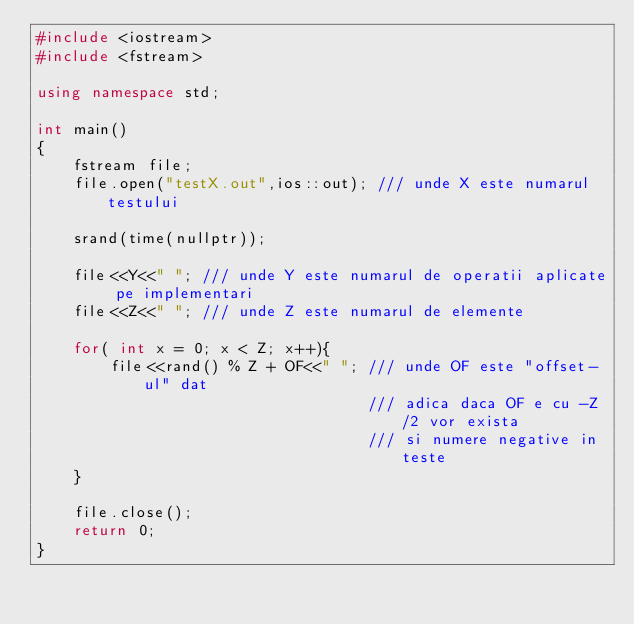Convert code to text. <code><loc_0><loc_0><loc_500><loc_500><_C++_>#include <iostream>
#include <fstream>

using namespace std;

int main()
{
    fstream file;
    file.open("testX.out",ios::out); /// unde X este numarul testului

    srand(time(nullptr));

    file<<Y<<" "; /// unde Y este numarul de operatii aplicate pe implementari
    file<<Z<<" "; /// unde Z este numarul de elemente

    for( int x = 0; x < Z; x++){
        file<<rand() % Z + OF<<" "; /// unde OF este "offset-ul" dat
                                    /// adica daca OF e cu -Z/2 vor exista
                                    /// si numere negative in teste
    }

    file.close();
    return 0;
}
</code> 